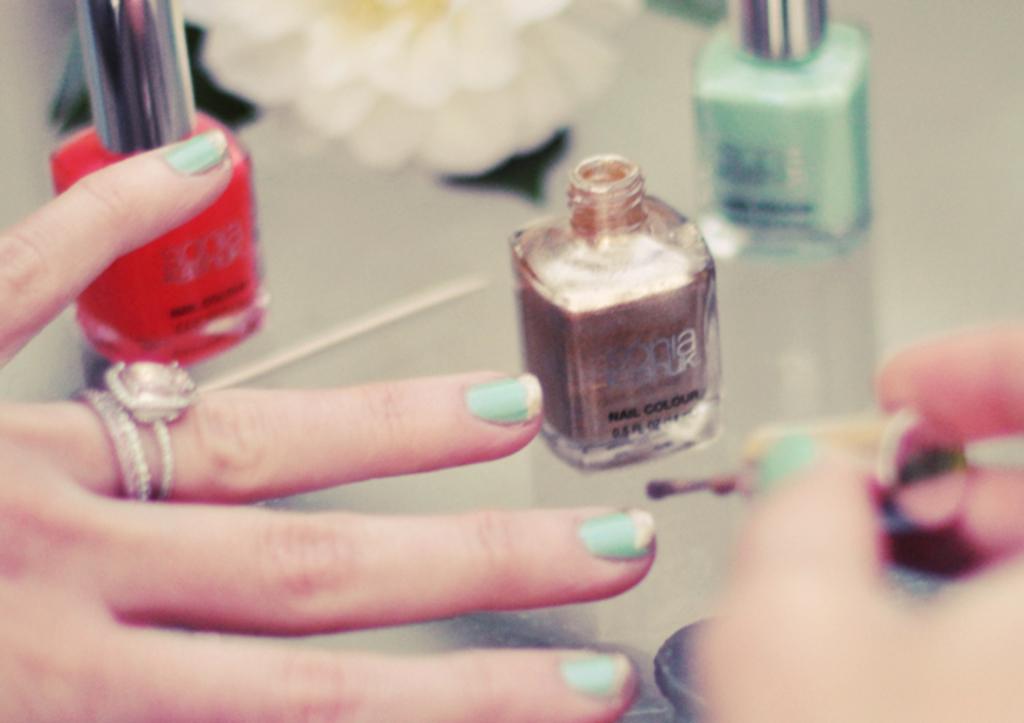What is are the words in black text on the gold nail polish?
Your response must be concise. Nail colour. 